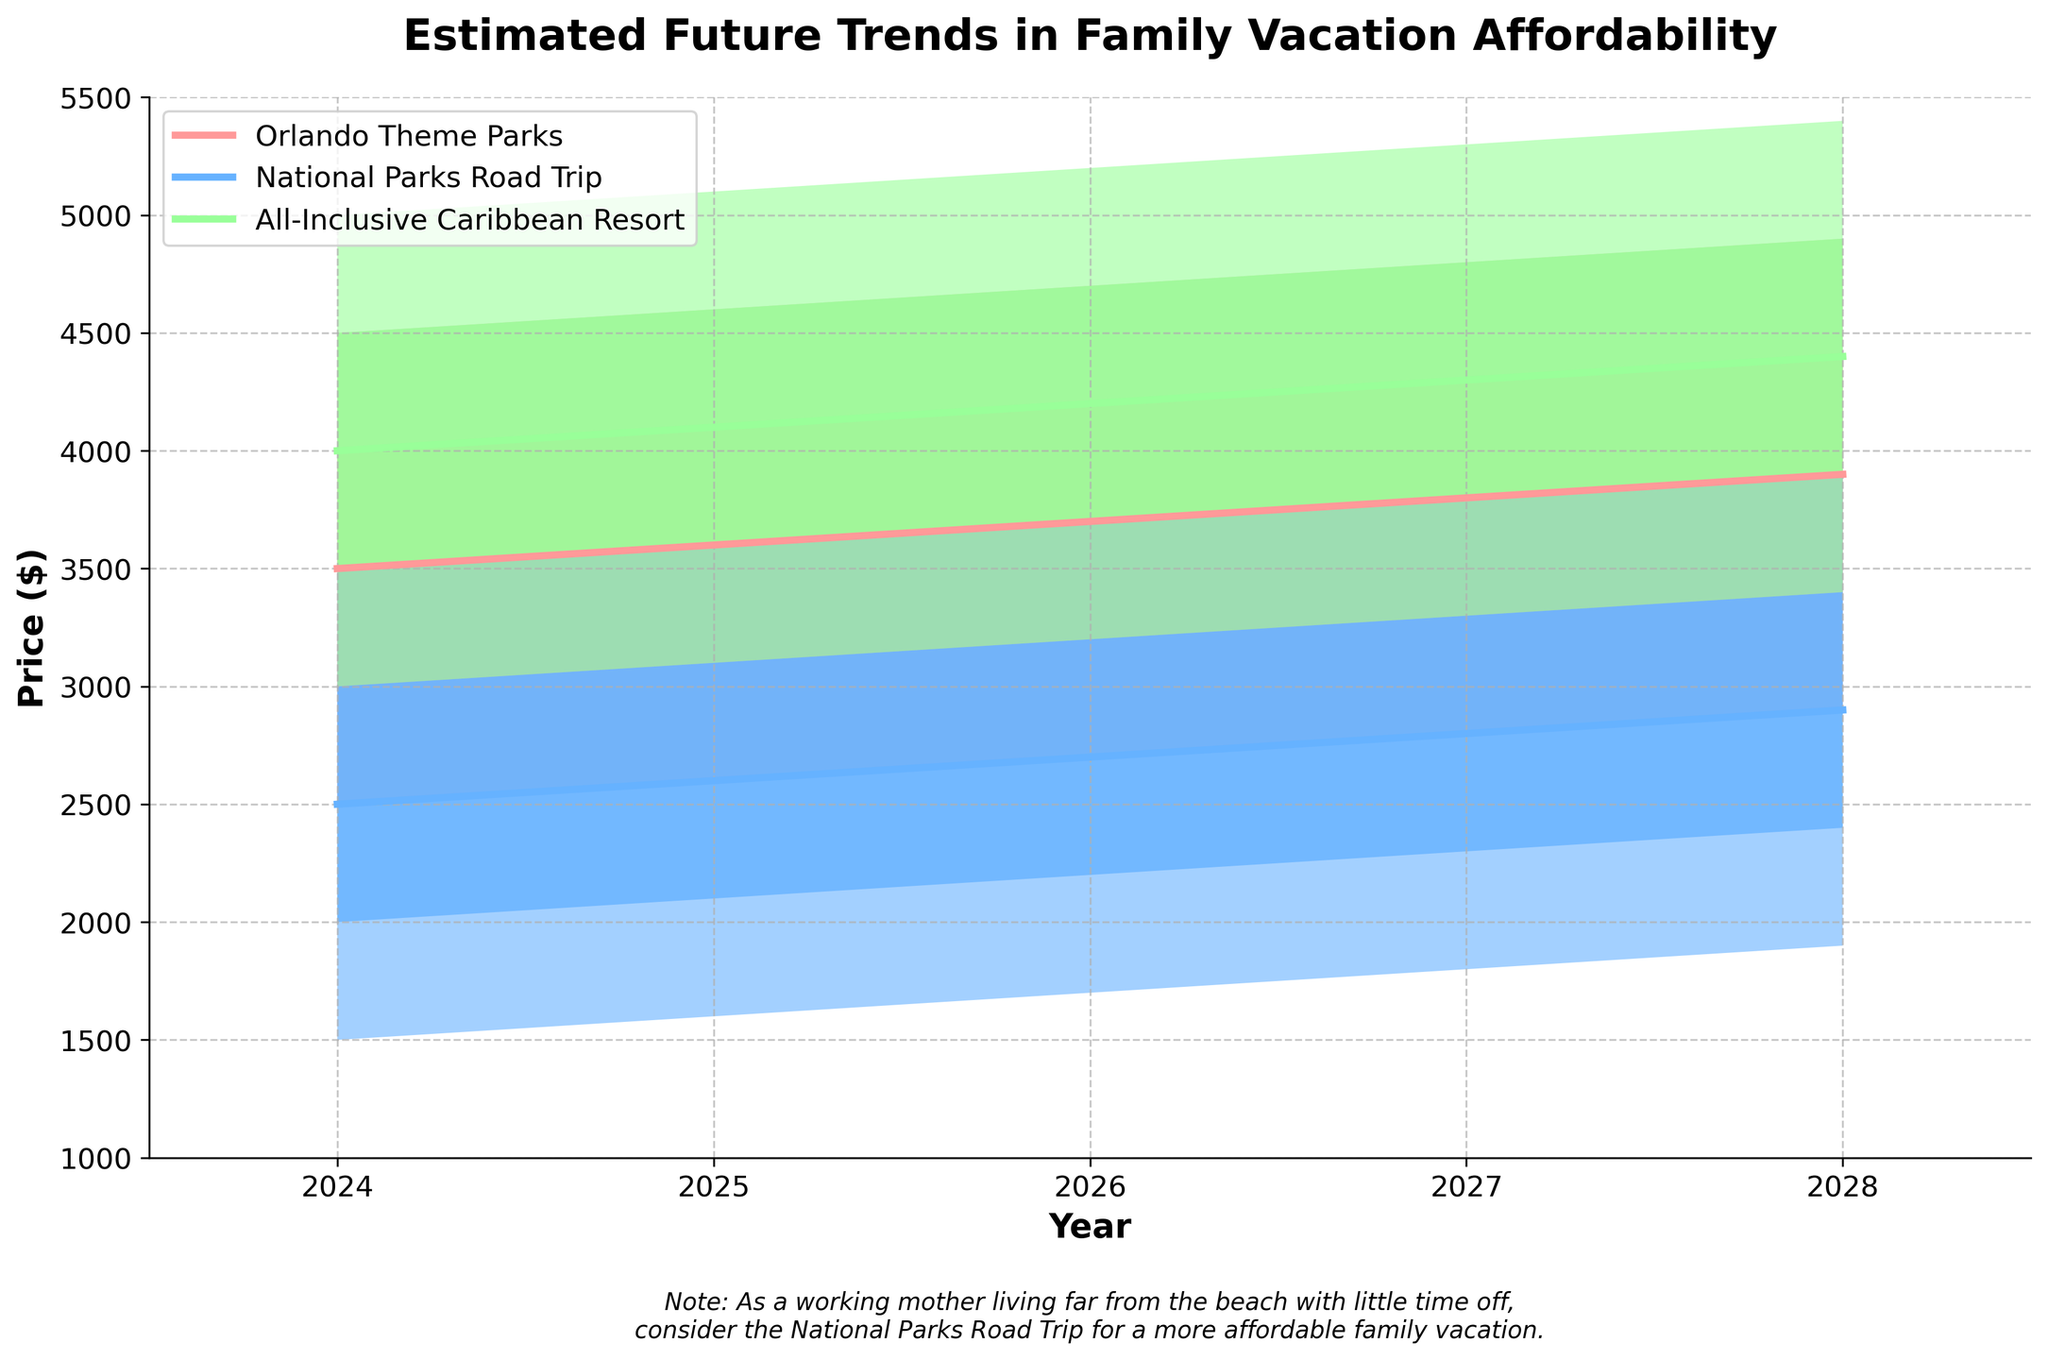What's the title of the figure? The title of the figure is located at the top and describes what the graph is about. By looking at the top of the figure, we see that it is "Estimated Future Trends in Family Vacation Affordability".
Answer: Estimated Future Trends in Family Vacation Affordability Between 2024 and 2028, which vacation type sees the highest increase in the Mid value? First, find the Mid values for all vacation types in 2024 and 2028. For Orlando Theme Parks, it goes from 3500 to 3900 (increase of 400). For National Parks Road Trip, it goes from 2500 to 2900 (increase of 400). For All-Inclusive Caribbean Resort, it goes from 4000 to 4400 (increase of 400). Since all have the same increase of 400, choose any as highest.
Answer: Orlando Theme Parks/Any What is the estimated price range for a National Parks Road Trip in 2026? By looking at the fan chart for the year 2026 under the National Parks Road Trip, we can see the shaded area from the lowest to the highest price range. The price range goes from 1700 to 3700 dollars.
Answer: 1700 to 3700 Which vacation type has the highest High value in 2027? By comparing the High values in 2027 across all three vacation types, we see that Orlando Theme Parks have 4800, National Parks Road Trip have 3800, and All-Inclusive Caribbean Resort has 5300. The highest value is for All-Inclusive Caribbean Resort.
Answer: All-Inclusive Caribbean Resort What is the price difference between the Mid-High and Low-Mid estimates for Orlando Theme Parks in 2028? First, find the Mid-High and Low-Mid values for Orlando Theme Parks in 2028. Mid-High is 4400 and Low-Mid is 3400. The difference is 4400 - 3400.
Answer: 1000 How does the affordability of National Parks Road Trip compare to an All-Inclusive Caribbean Resort in 2025 in terms of their Mid values? Compare the Mid values for both vacations in 2025. The National Parks Road Trip has a Mid value of 2600, and the All-Inclusive Caribbean Resort has a Mid value of 4100. National Parks Road Trip is more affordable.
Answer: National Parks Road Trip Does any vacation type have a decreasing trend in any of the price estimates? Examine the chart to see if any price estimate (Low, Low-Mid, Mid, Mid-High, High) decreases from year to year. All estimates for all vacation types increase over the years shown.
Answer: No Which year shows a higher Mid value for Orlando Theme Parks: 2024 or 2025? Compare the Mid values for Orlando Theme Parks in 2024 and 2025. The Mid value in 2024 is 3500 and in 2025 is 3600. 2025 shows a higher Mid value.
Answer: 2025 What is the average of the Low-Mid values for All-Inclusive Caribbean Resort from 2024 to 2028? Calculate the Low-Mid values from 2024 (3500), 2025 (3600), 2026 (3700), 2027 (3800), and 2028 (3900). Sum these up and divide by the number of years (5). (3500 + 3600 + 3700 + 3800 + 3900) / 5 = 3700.
Answer: 3700 